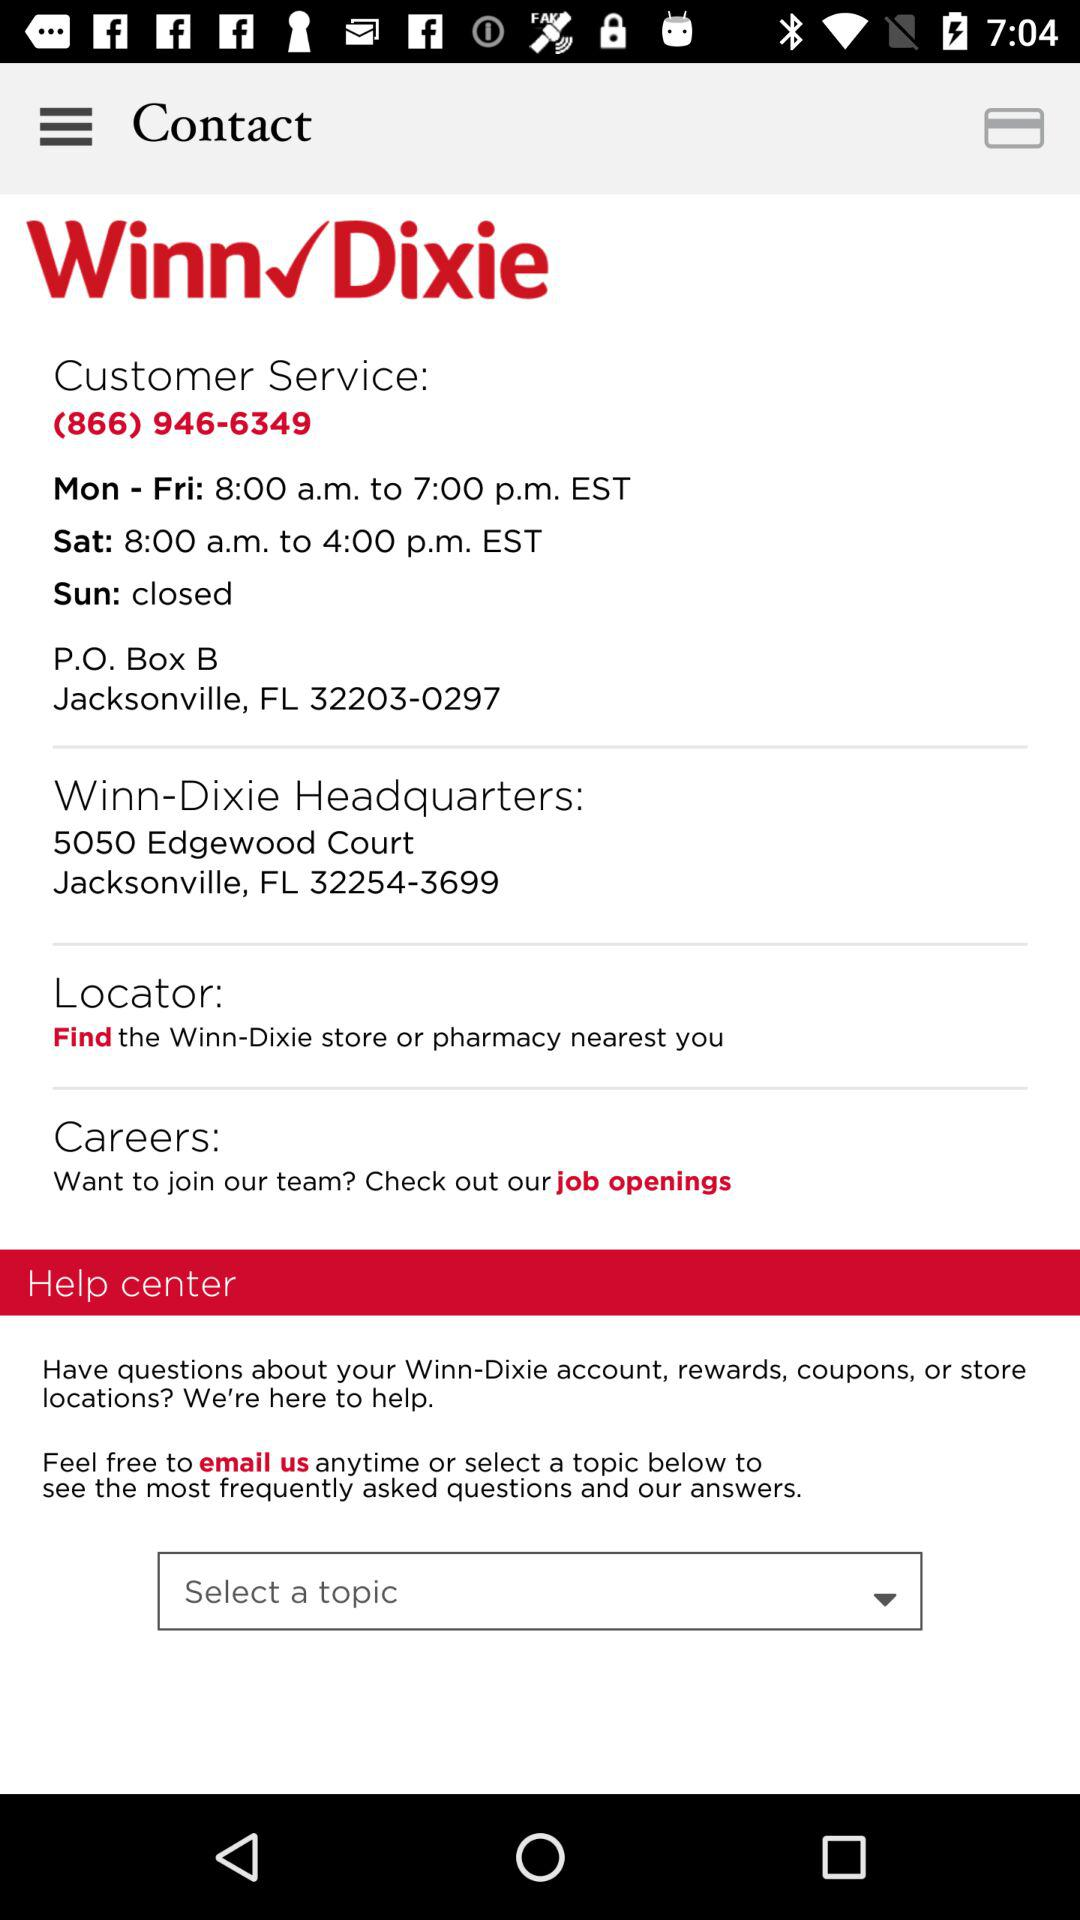What are the opening hours from Monday to Friday? The opening hours are from 8:00 a.m. to 7:00 p.m. EST. 